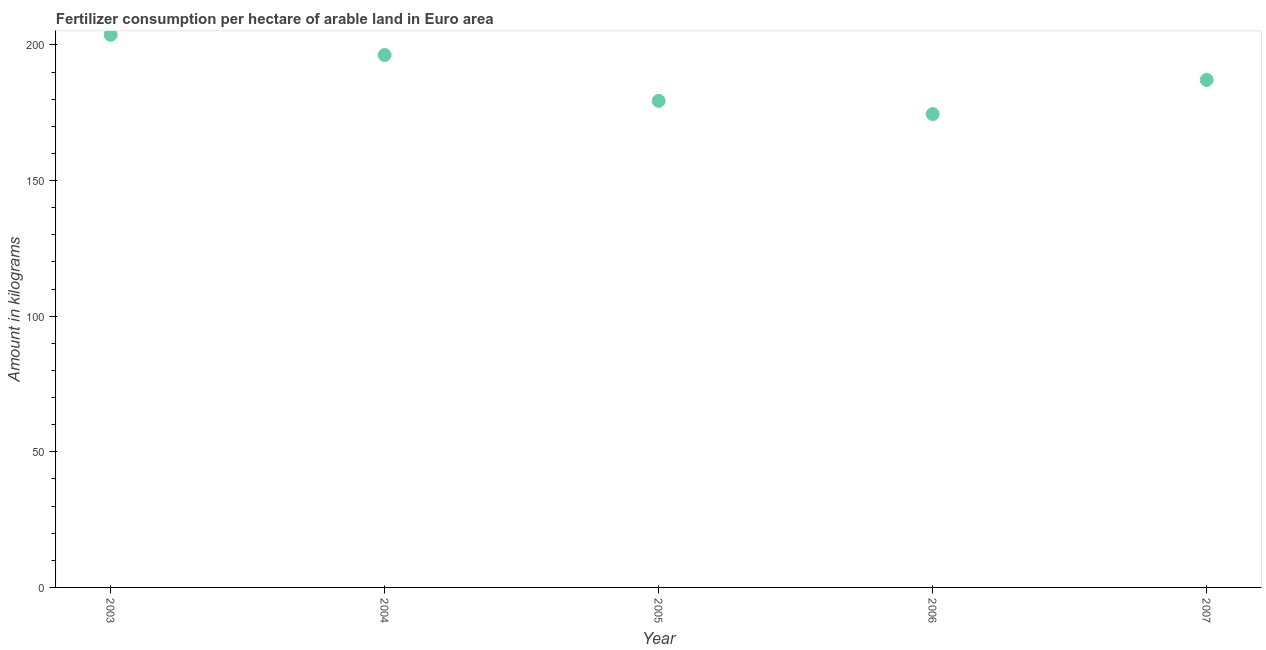What is the amount of fertilizer consumption in 2003?
Provide a short and direct response. 203.76. Across all years, what is the maximum amount of fertilizer consumption?
Provide a short and direct response. 203.76. Across all years, what is the minimum amount of fertilizer consumption?
Your answer should be compact. 174.52. What is the sum of the amount of fertilizer consumption?
Provide a short and direct response. 941.12. What is the difference between the amount of fertilizer consumption in 2004 and 2007?
Make the answer very short. 9.19. What is the average amount of fertilizer consumption per year?
Ensure brevity in your answer.  188.22. What is the median amount of fertilizer consumption?
Keep it short and to the point. 187.12. Do a majority of the years between 2007 and 2004 (inclusive) have amount of fertilizer consumption greater than 80 kg?
Offer a terse response. Yes. What is the ratio of the amount of fertilizer consumption in 2005 to that in 2007?
Your answer should be very brief. 0.96. Is the amount of fertilizer consumption in 2003 less than that in 2007?
Make the answer very short. No. Is the difference between the amount of fertilizer consumption in 2003 and 2004 greater than the difference between any two years?
Your answer should be compact. No. What is the difference between the highest and the second highest amount of fertilizer consumption?
Provide a succinct answer. 7.45. Is the sum of the amount of fertilizer consumption in 2006 and 2007 greater than the maximum amount of fertilizer consumption across all years?
Your response must be concise. Yes. What is the difference between the highest and the lowest amount of fertilizer consumption?
Make the answer very short. 29.24. How many dotlines are there?
Ensure brevity in your answer.  1. How many years are there in the graph?
Your answer should be very brief. 5. Does the graph contain any zero values?
Offer a terse response. No. What is the title of the graph?
Offer a terse response. Fertilizer consumption per hectare of arable land in Euro area . What is the label or title of the X-axis?
Offer a very short reply. Year. What is the label or title of the Y-axis?
Offer a terse response. Amount in kilograms. What is the Amount in kilograms in 2003?
Give a very brief answer. 203.76. What is the Amount in kilograms in 2004?
Provide a succinct answer. 196.31. What is the Amount in kilograms in 2005?
Offer a very short reply. 179.4. What is the Amount in kilograms in 2006?
Offer a terse response. 174.52. What is the Amount in kilograms in 2007?
Offer a very short reply. 187.12. What is the difference between the Amount in kilograms in 2003 and 2004?
Offer a terse response. 7.45. What is the difference between the Amount in kilograms in 2003 and 2005?
Give a very brief answer. 24.37. What is the difference between the Amount in kilograms in 2003 and 2006?
Your response must be concise. 29.24. What is the difference between the Amount in kilograms in 2003 and 2007?
Provide a succinct answer. 16.64. What is the difference between the Amount in kilograms in 2004 and 2005?
Ensure brevity in your answer.  16.92. What is the difference between the Amount in kilograms in 2004 and 2006?
Make the answer very short. 21.79. What is the difference between the Amount in kilograms in 2004 and 2007?
Your answer should be compact. 9.19. What is the difference between the Amount in kilograms in 2005 and 2006?
Offer a terse response. 4.87. What is the difference between the Amount in kilograms in 2005 and 2007?
Give a very brief answer. -7.73. What is the difference between the Amount in kilograms in 2006 and 2007?
Provide a short and direct response. -12.6. What is the ratio of the Amount in kilograms in 2003 to that in 2004?
Your answer should be very brief. 1.04. What is the ratio of the Amount in kilograms in 2003 to that in 2005?
Your answer should be very brief. 1.14. What is the ratio of the Amount in kilograms in 2003 to that in 2006?
Offer a terse response. 1.17. What is the ratio of the Amount in kilograms in 2003 to that in 2007?
Offer a terse response. 1.09. What is the ratio of the Amount in kilograms in 2004 to that in 2005?
Provide a short and direct response. 1.09. What is the ratio of the Amount in kilograms in 2004 to that in 2006?
Ensure brevity in your answer.  1.12. What is the ratio of the Amount in kilograms in 2004 to that in 2007?
Your answer should be compact. 1.05. What is the ratio of the Amount in kilograms in 2005 to that in 2006?
Your answer should be very brief. 1.03. What is the ratio of the Amount in kilograms in 2005 to that in 2007?
Offer a very short reply. 0.96. What is the ratio of the Amount in kilograms in 2006 to that in 2007?
Your answer should be very brief. 0.93. 